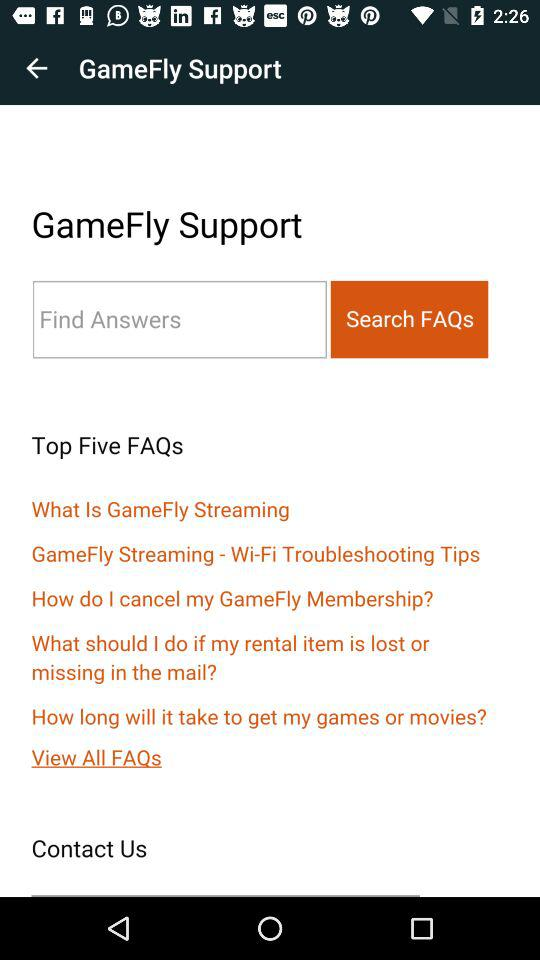What is the name of the application? The name of the application is "GameFly". 